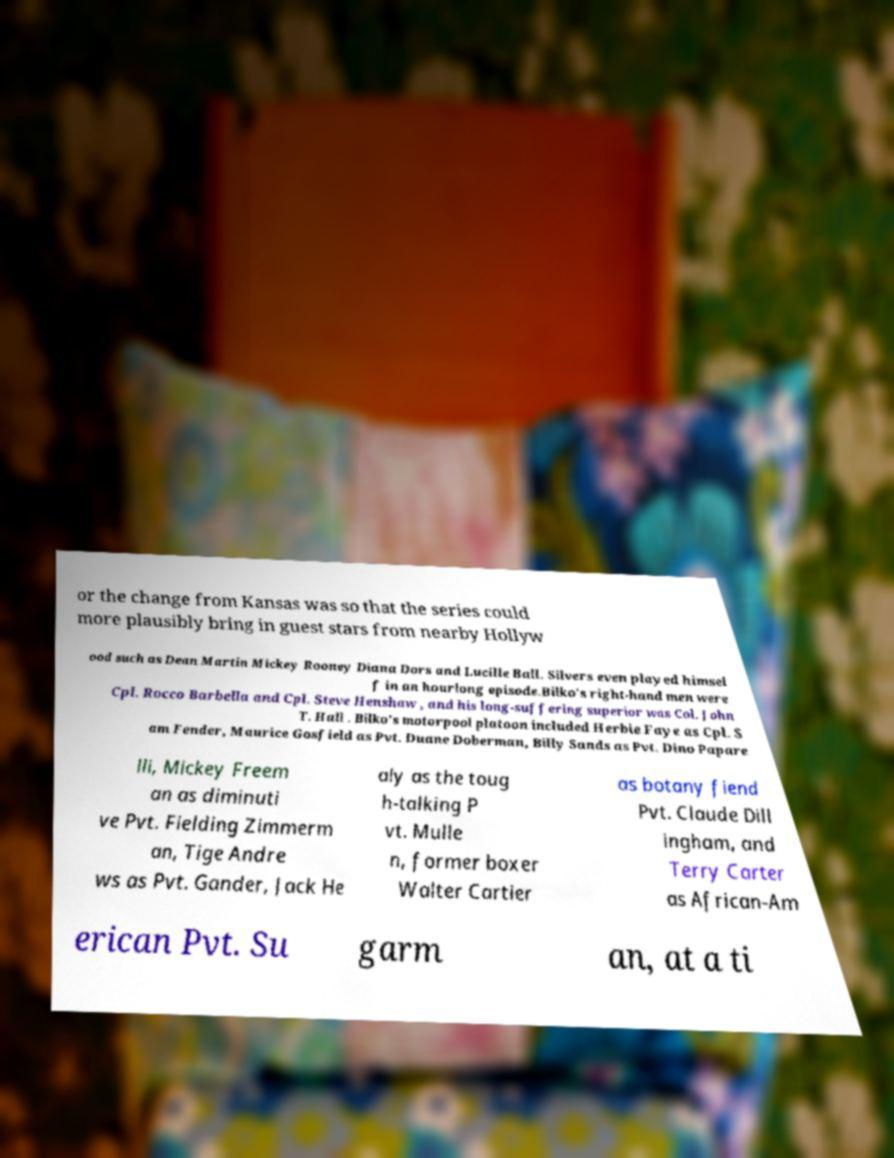What messages or text are displayed in this image? I need them in a readable, typed format. or the change from Kansas was so that the series could more plausibly bring in guest stars from nearby Hollyw ood such as Dean Martin Mickey Rooney Diana Dors and Lucille Ball. Silvers even played himsel f in an hourlong episode.Bilko's right-hand men were Cpl. Rocco Barbella and Cpl. Steve Henshaw , and his long-suffering superior was Col. John T. Hall . Bilko's motorpool platoon included Herbie Faye as Cpl. S am Fender, Maurice Gosfield as Pvt. Duane Doberman, Billy Sands as Pvt. Dino Papare lli, Mickey Freem an as diminuti ve Pvt. Fielding Zimmerm an, Tige Andre ws as Pvt. Gander, Jack He aly as the toug h-talking P vt. Mulle n, former boxer Walter Cartier as botany fiend Pvt. Claude Dill ingham, and Terry Carter as African-Am erican Pvt. Su garm an, at a ti 